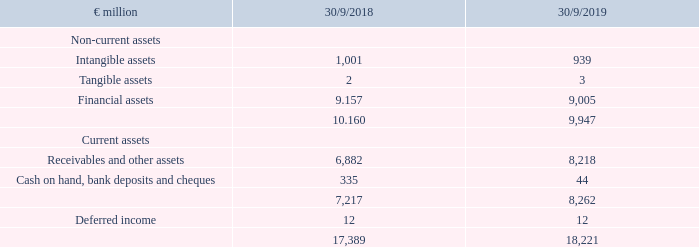Asset position of METRO AG
ASSETS
As of the closing date, METRO had total assets of €18,221 million, which are predominantly comprised of financial assets in the amount of €9,005 million, receivables from affiliated companies at €8,214 million and the usufructuary rights to the METRO and MAKRO brands which were recognised as an intangible asset (€883 million). Cash on hand, bank deposits and cheques amounted to €44 million. The financial assets predominantly consist of shares held in affiliated companies in the amount of €8,964 million which are essentially comprised of shares in the holding for wholesale companies (€6,693 million), in real estate companies (€1,278 million), in service providers (€470 million) and in other companies (€523 million). The financial assets account for 49.4% of the total assets. Receivables from affiliated companies amount to €8,214 million. This corresponds to 45.1% of the total assets. This position contains €6,117 million in receivables from a group-internal transfer of shares in affiliated companies at their carrying values and predominantly reflects the short-term financing requirements of the group companies as of the closing date.
What was METRO's total assets in FY2019? €18,221 million. What was the amount of financial assets in FY2019? €9,005 million. What are the types of assets under Non-current assets in the table? Intangible assets, tangible assets, financial assets. In which year was the amount of total assets larger? 18,221>17,389
Answer: 2019. What was the change in total assets in FY2019 from FY2018?
Answer scale should be: million. 18,221-17,389
Answer: 832. What was the percentage change in total assets in FY2019 from FY2018?
Answer scale should be: percent. (18,221-17,389)/17,389
Answer: 4.78. 